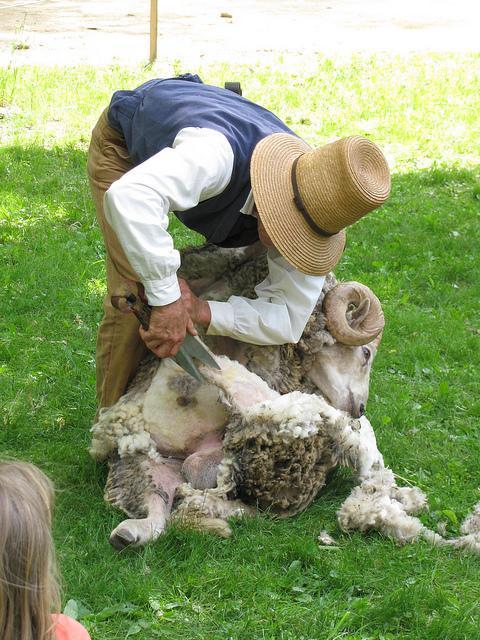How many sheep are in the picture?
Give a very brief answer. 1. How many people are there?
Give a very brief answer. 2. How many boats can be seen?
Give a very brief answer. 0. 